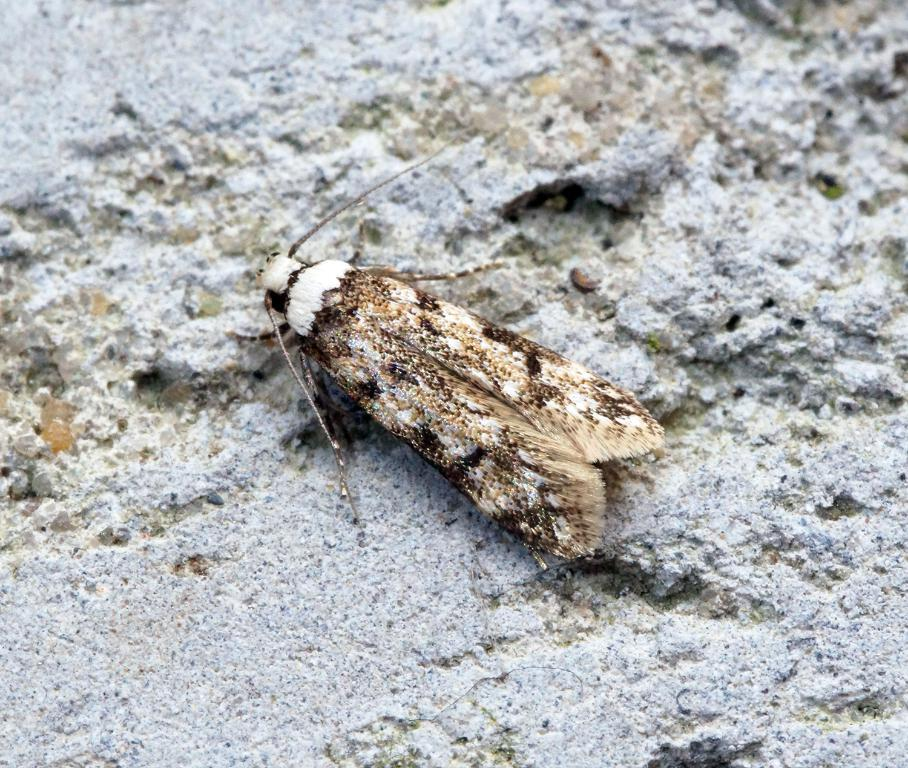What is located in the center of the image? There is an insect in the center of the image. Can you describe the appearance of the insect? The insect has brown and white colors. What type of furniture can be seen in the image? There is no furniture present in the image; it features an insect in the center. What is the end result of the insect's journey in the image? The image does not depict a journey or an end result for the insect; it simply shows the insect in the center. 